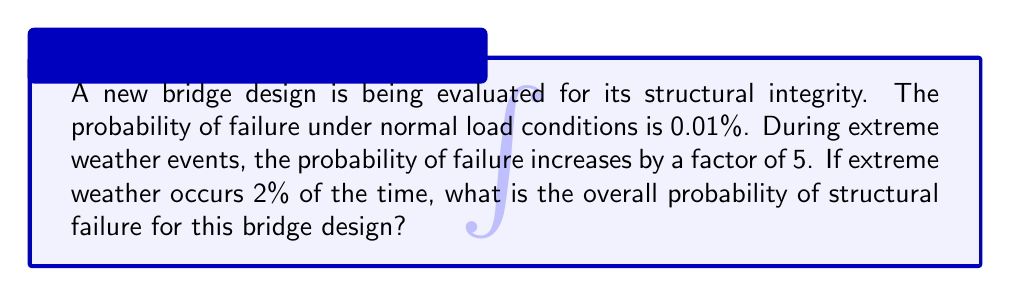Provide a solution to this math problem. Let's approach this step-by-step:

1) Define the events:
   A: Bridge fails
   B: Extreme weather occurs

2) Given probabilities:
   $P(A|B^c) = 0.0001$ (probability of failure under normal conditions)
   $P(A|B) = 5 \times 0.0001 = 0.0005$ (probability of failure during extreme weather)
   $P(B) = 0.02$ (probability of extreme weather)

3) We can use the law of total probability:
   $$P(A) = P(A|B)P(B) + P(A|B^c)P(B^c)$$

4) Calculate $P(B^c)$:
   $P(B^c) = 1 - P(B) = 1 - 0.02 = 0.98$

5) Substitute the values into the formula:
   $$P(A) = (0.0005)(0.02) + (0.0001)(0.98)$$

6) Compute:
   $$P(A) = 0.00001 + 0.000098 = 0.000108$$

7) Convert to percentage:
   $0.000108 \times 100\% = 0.0108\%$
Answer: 0.0108% 